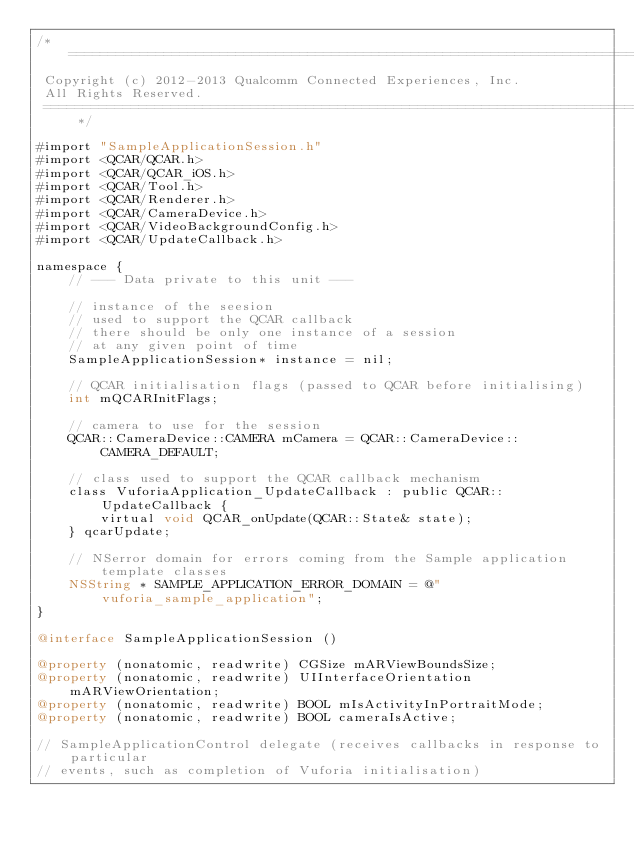Convert code to text. <code><loc_0><loc_0><loc_500><loc_500><_ObjectiveC_>/*==============================================================================
 Copyright (c) 2012-2013 Qualcomm Connected Experiences, Inc.
 All Rights Reserved.
 ==============================================================================*/

#import "SampleApplicationSession.h"
#import <QCAR/QCAR.h>
#import <QCAR/QCAR_iOS.h>
#import <QCAR/Tool.h>
#import <QCAR/Renderer.h>
#import <QCAR/CameraDevice.h>
#import <QCAR/VideoBackgroundConfig.h>
#import <QCAR/UpdateCallback.h>

namespace {
    // --- Data private to this unit ---
    
    // instance of the seesion
    // used to support the QCAR callback
    // there should be only one instance of a session
    // at any given point of time
    SampleApplicationSession* instance = nil;
    
    // QCAR initialisation flags (passed to QCAR before initialising)
    int mQCARInitFlags;
    
    // camera to use for the session
    QCAR::CameraDevice::CAMERA mCamera = QCAR::CameraDevice::CAMERA_DEFAULT;
    
    // class used to support the QCAR callback mechanism
    class VuforiaApplication_UpdateCallback : public QCAR::UpdateCallback {
        virtual void QCAR_onUpdate(QCAR::State& state);
    } qcarUpdate;

    // NSerror domain for errors coming from the Sample application template classes
    NSString * SAMPLE_APPLICATION_ERROR_DOMAIN = @"vuforia_sample_application";
}

@interface SampleApplicationSession ()

@property (nonatomic, readwrite) CGSize mARViewBoundsSize;
@property (nonatomic, readwrite) UIInterfaceOrientation mARViewOrientation;
@property (nonatomic, readwrite) BOOL mIsActivityInPortraitMode;
@property (nonatomic, readwrite) BOOL cameraIsActive;

// SampleApplicationControl delegate (receives callbacks in response to particular
// events, such as completion of Vuforia initialisation)</code> 